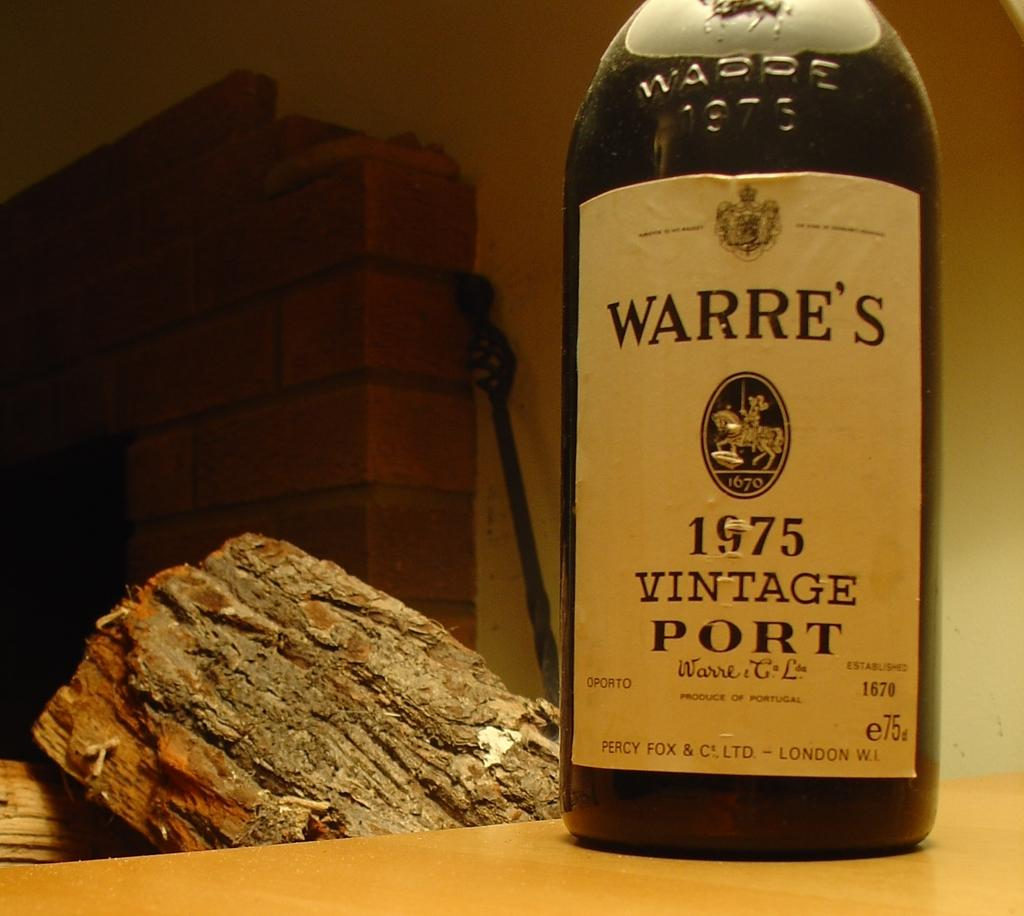<image>
Write a terse but informative summary of the picture. A glass bottle of vintage Port wine standing in front of a wooden log and fireplace. 